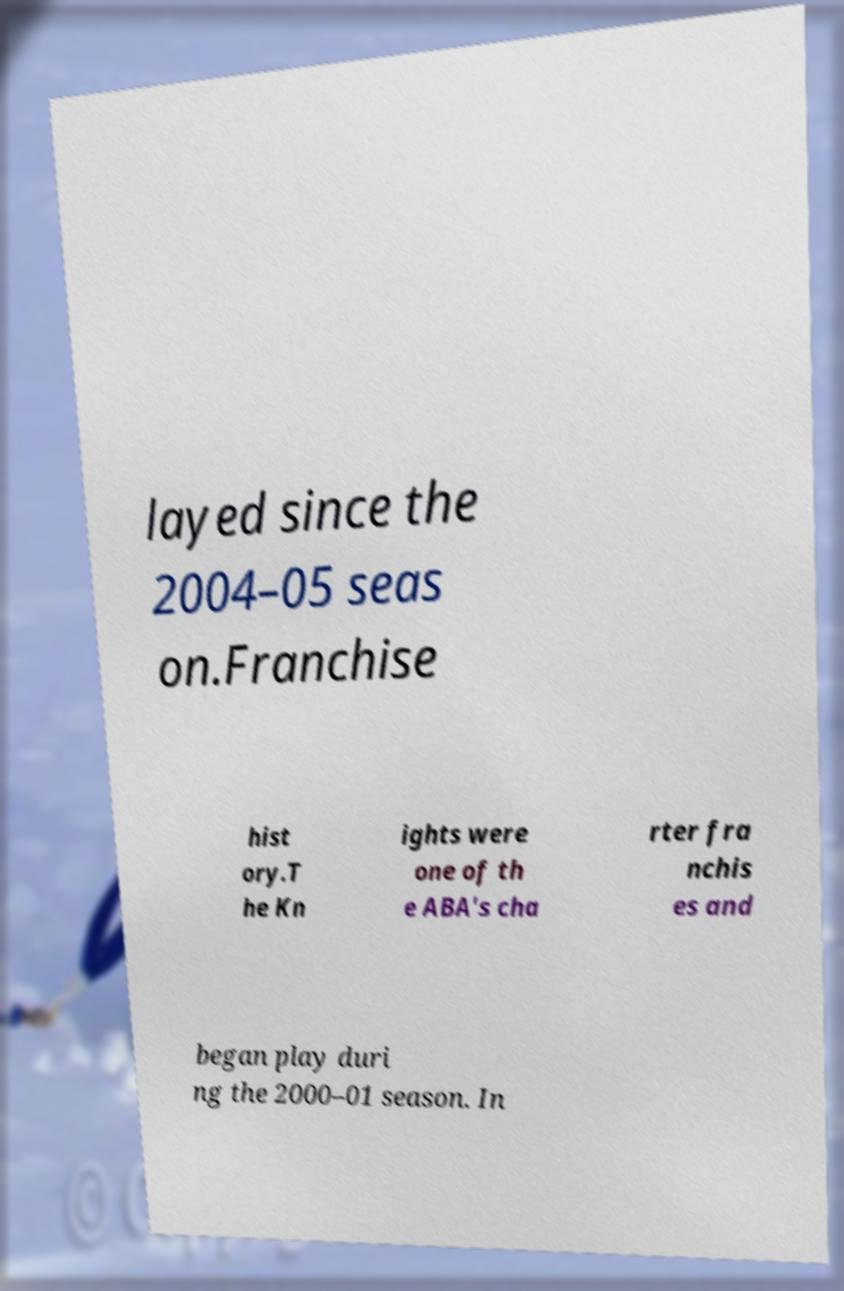I need the written content from this picture converted into text. Can you do that? layed since the 2004–05 seas on.Franchise hist ory.T he Kn ights were one of th e ABA's cha rter fra nchis es and began play duri ng the 2000–01 season. In 